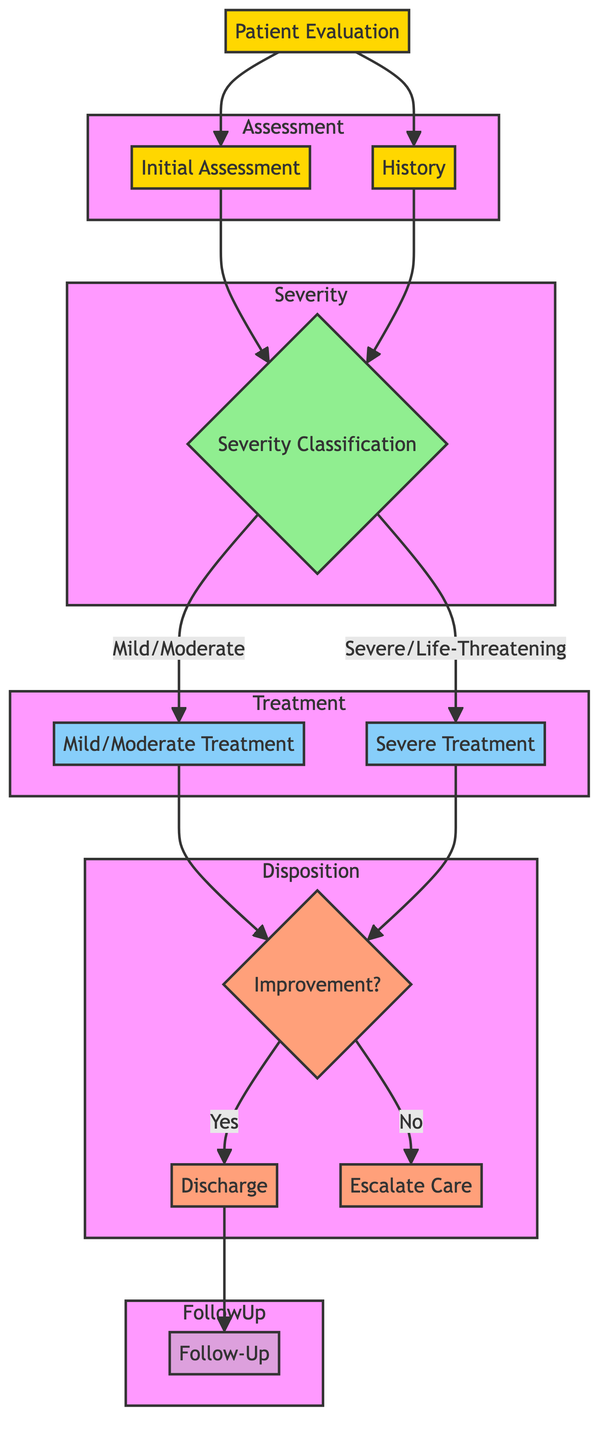What are the two components of Patient Evaluation? The diagram shows that Patient Evaluation consists of Initial Assessment and History. These nodes detail the subcomponents to focus on during the evaluation phase.
Answer: Initial Assessment, History How many treatment types are listed in the diagram? The diagram lists two treatment types: Mild/Moderate Treatment and Severe Treatment. These are the classifications indicated under Treatment.
Answer: 2 What is the threshold for O2 Saturation in Severe/Life-Threatening classification? The Severe/Life-Threatening classification specifies that O2 Saturation must be less than or equal to 92%. This threshold is part of the criteria outlined in the diagram.
Answer: 92% What action is taken if there is improvement after Mild/Moderate Treatment? If improvement is noted after Mild/Moderate Treatment, the next action is Discharge. This outcome is indicated in the pathway demonstrating the flow of care.
Answer: Discharge What is recommended if the patient shows No Improvement? The diagram states that if there is no improvement, Continuous nebulization and ICU Admission are necessary, indicating the need for escalated care.
Answer: Continuous nebulization, ICU Admission How often should the patient be reassessed after Severe Treatment? The diagram emphasizes that reassessment should occur every 15-30 minutes after Severe Treatment. This timeline is critical to monitoring the patient's status.
Answer: Every 15-30 minutes What is included in the Follow-Up section? The Follow-Up section outlines multiple components, including continuing Inhaled Corticosteroids and scheduling a follow-up with a primary care provider or allergist.
Answer: Continue Inhaled Corticosteroids, Avoid Triggers, Adherence to Asthma Action Plan, Schedule Follow-up with PCP or Allergist 